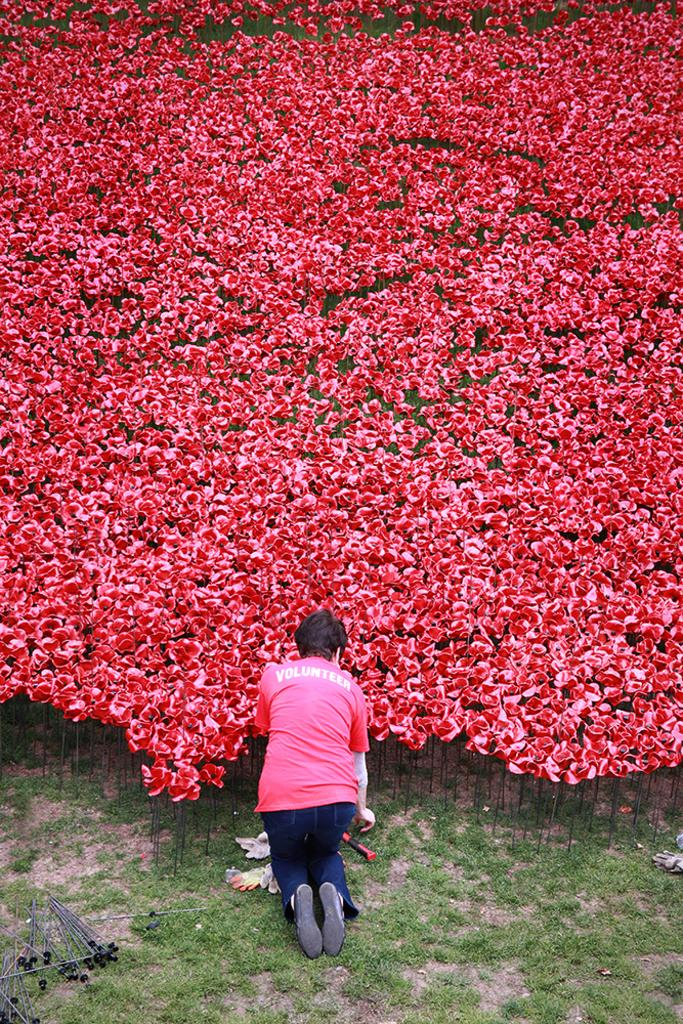What can be seen on the ground in the foreground of the image? There are rod-like structures on the ground in the foreground of the image. What is the person in the foreground of the image doing? A person is kneeling down in the foreground of the image. What type of plants can be seen in the image? There are flowers visible in the image. What effect does the queen have on the story in the image? There is no queen or story present in the image; it features rod-like structures, a person kneeling down, and flowers. 